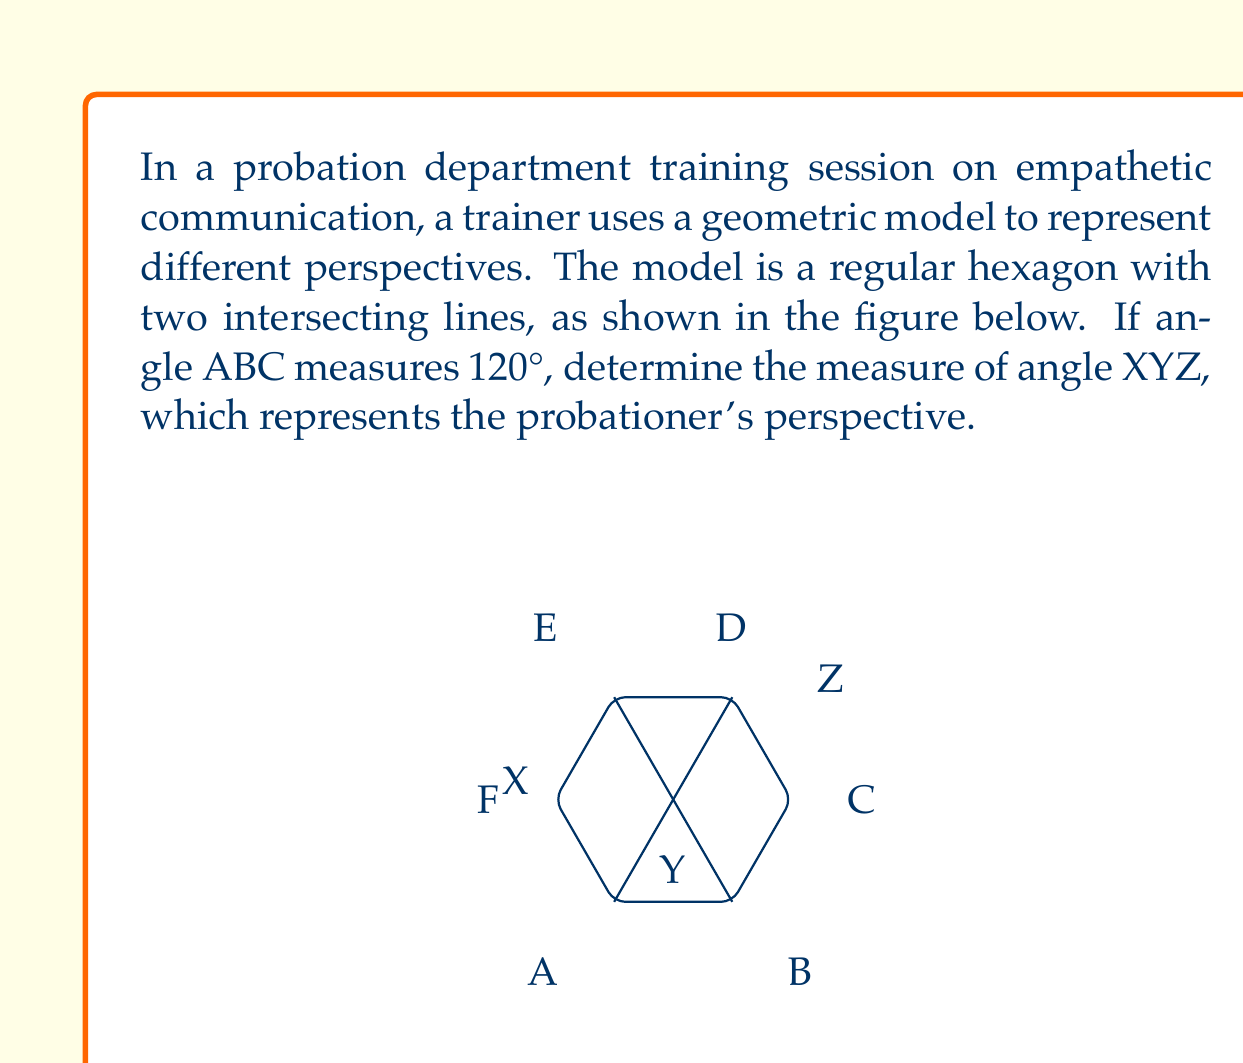Give your solution to this math problem. Let's approach this step-by-step:

1) In a regular hexagon, all interior angles measure 120°. This is because the sum of interior angles of a hexagon is $(n-2) \times 180°$, where $n$ is the number of sides. So, $(6-2) \times 180° = 720°$. Dividing this by 6 gives us 120° for each angle.

2) The two intersecting lines (AD and BE) divide the hexagon into six triangles.

3) Focus on triangle ABC. We know that:
   - Angle ABC = 120° (given)
   - Angle BAC = 60° (half of the hexagon's interior angle)

4) The sum of angles in a triangle is 180°. So:
   $$\angle BCA = 180° - 120° - 60° = 0°$$

5) This means that points A, C, and D are collinear (they form a straight line).

6) Now, look at triangle XYZ:
   - Angle XYZ + Angle YXZ + Angle YZX = 180° (sum of angles in a triangle)
   - Angle YXZ = 60° (half of the hexagon's interior angle)
   - Angle YZX = 60° (half of the hexagon's interior angle)

7) Therefore:
   $$\angle XYZ = 180° - 60° - 60° = 60°$$

This angle represents the probationer's perspective in the communication model.
Answer: The measure of angle XYZ is 60°. 